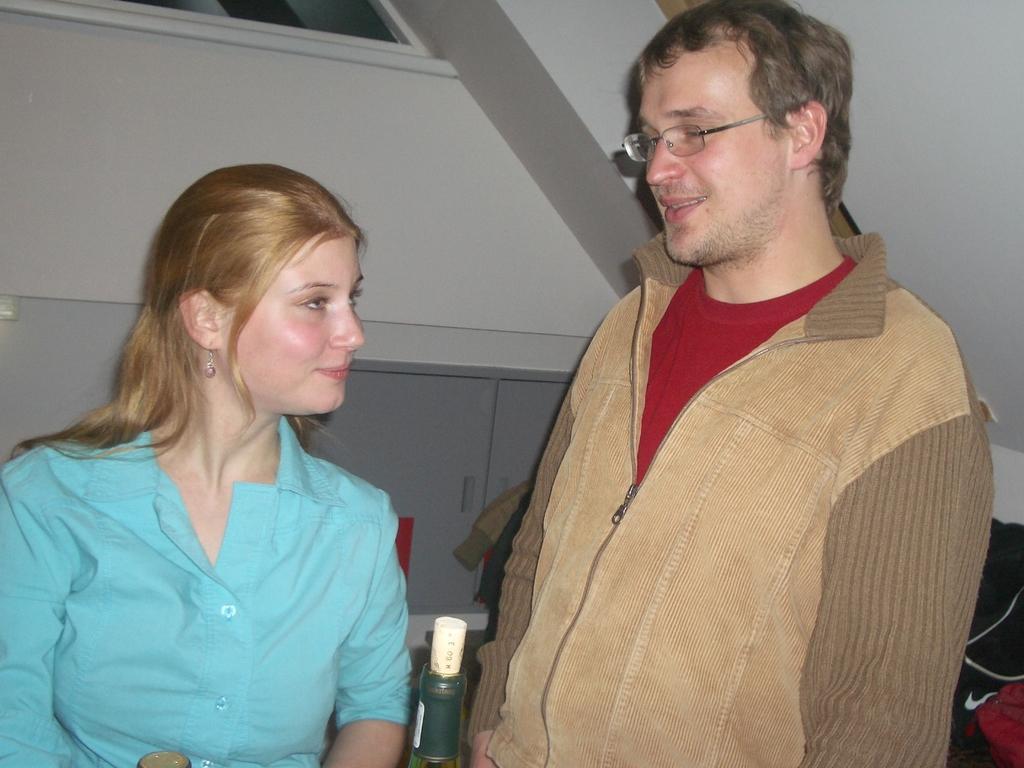How would you summarize this image in a sentence or two? In this picture there is a man on the right side of the image and there is a lady on the left side of the image, there is a window at the top side of the image. 